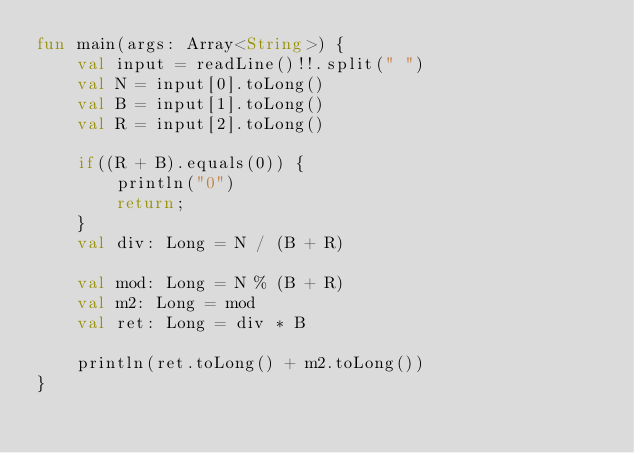Convert code to text. <code><loc_0><loc_0><loc_500><loc_500><_Kotlin_>fun main(args: Array<String>) {
    val input = readLine()!!.split(" ")
    val N = input[0].toLong()
    val B = input[1].toLong()
    val R = input[2].toLong()

    if((R + B).equals(0)) {
        println("0")
        return;
    }
    val div: Long = N / (B + R)
    
    val mod: Long = N % (B + R)
    val m2: Long = mod
    val ret: Long = div * B
    
    println(ret.toLong() + m2.toLong())
}</code> 